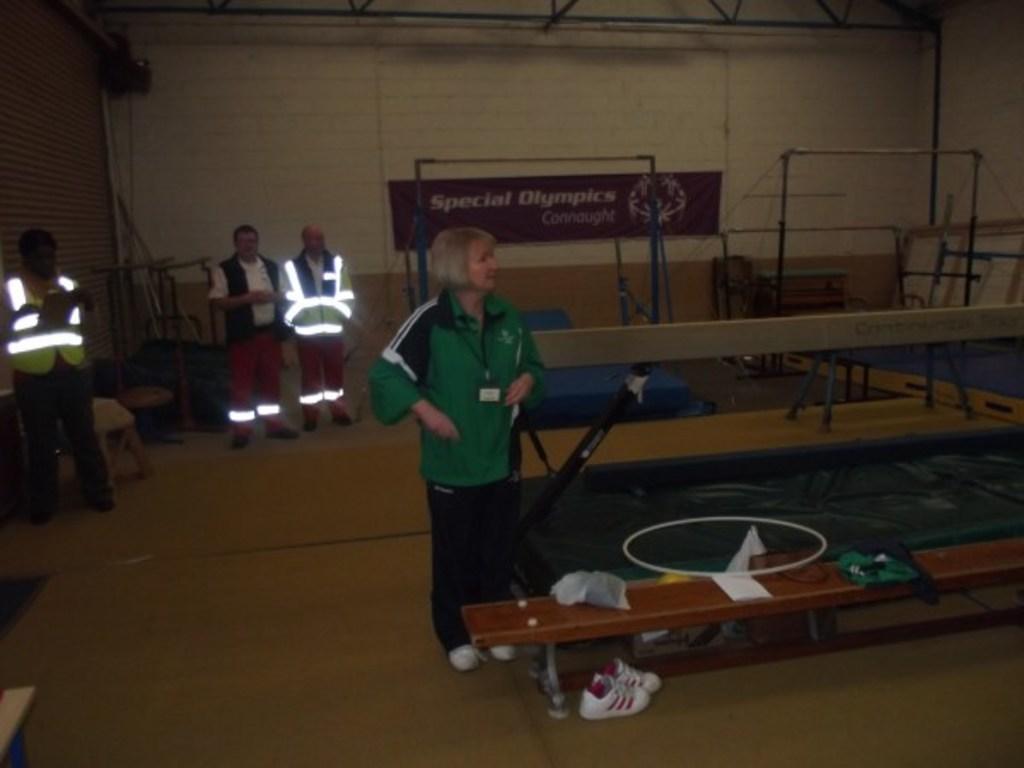Could you give a brief overview of what you see in this image? In this image I can see few people are standing here. I can also see a bench and a shoe. 